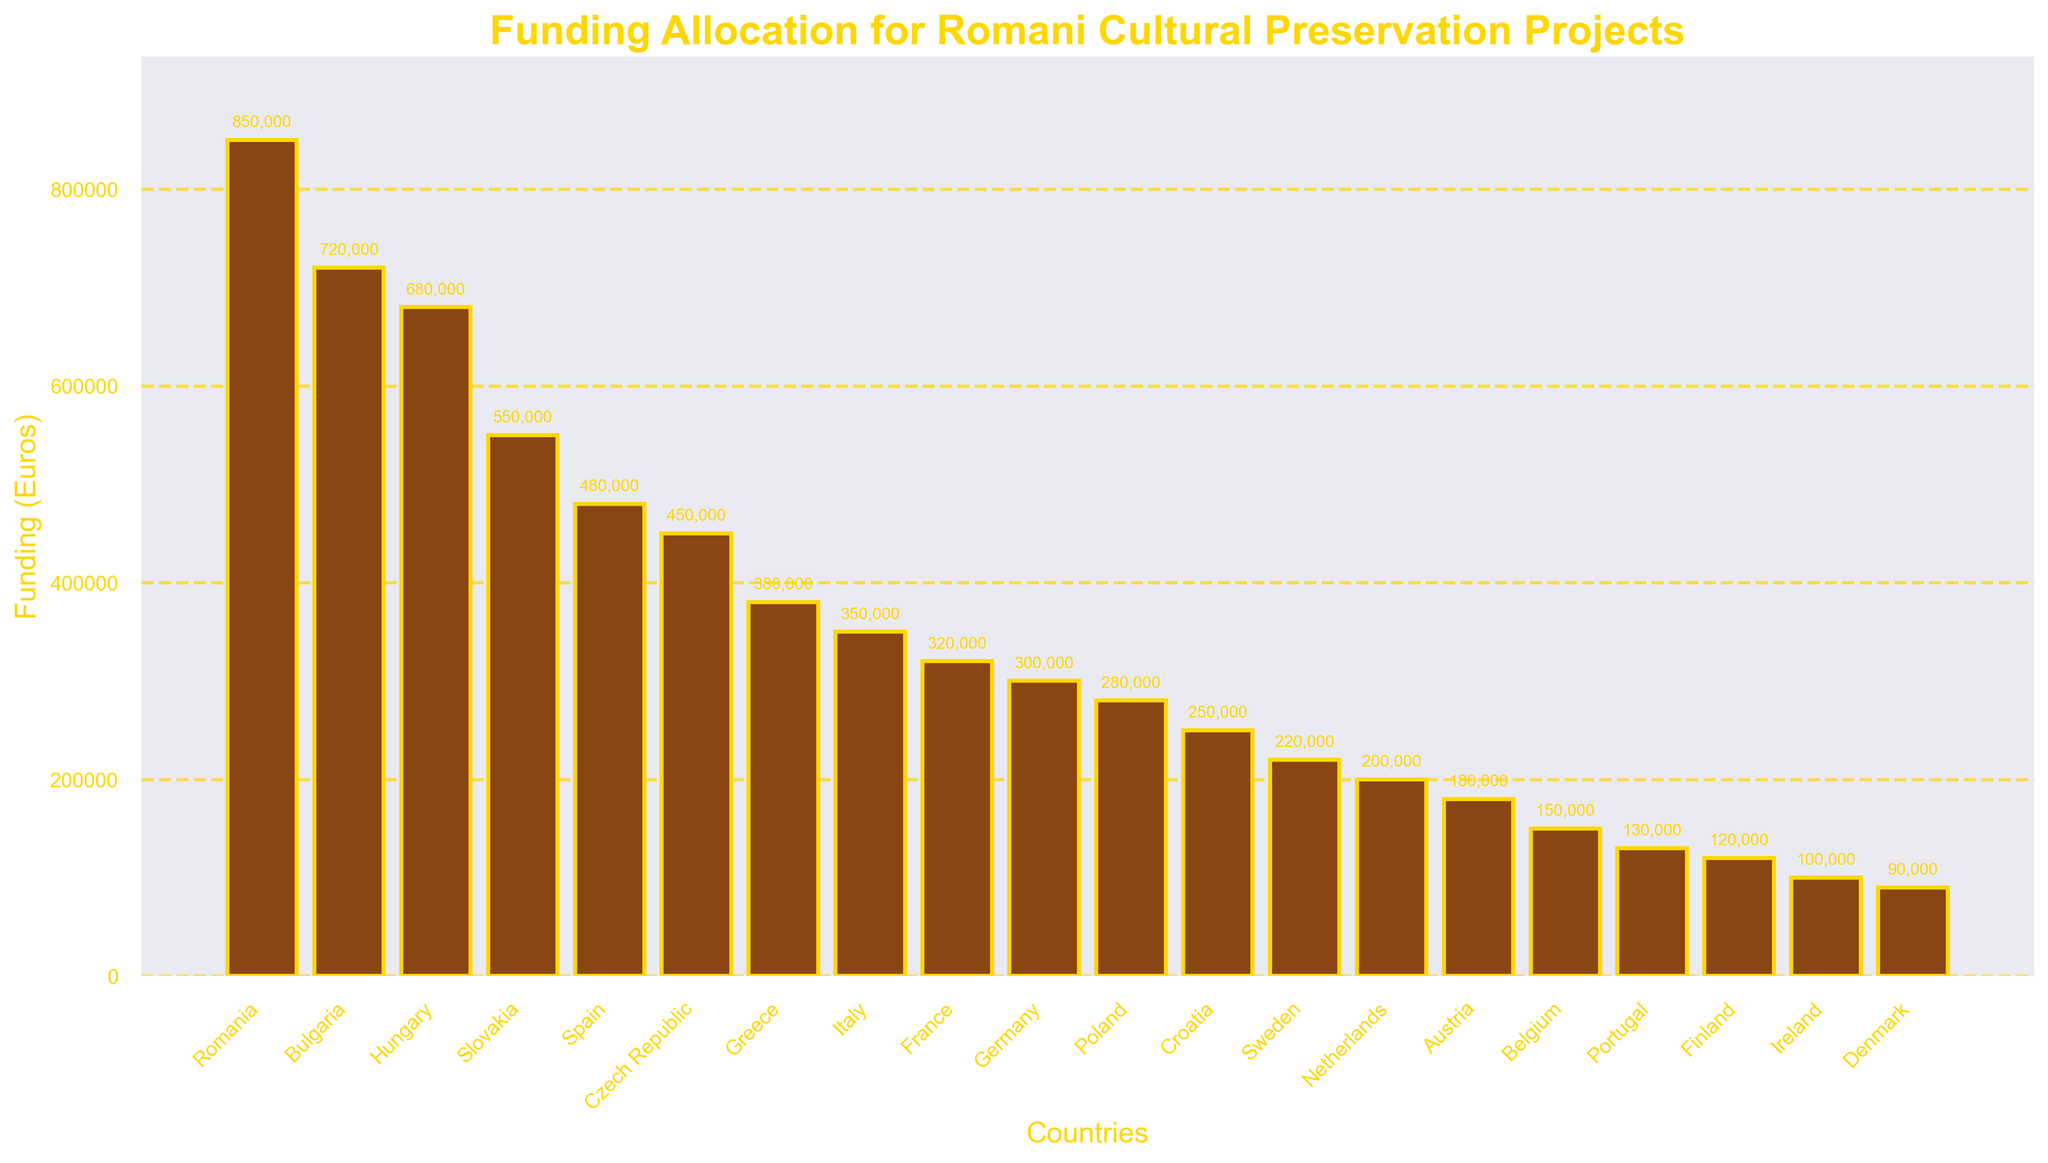what is the total funding allocated by the top three countries? Add the funding amounts for Romania, Bulgaria, and Hungary: 850,000 + 720,000 + 680,000 = 2,250,000 euros
Answer: 2,250,000 euros Which country received the least funding? Look at the bar with the smallest height; Denmark has the smallest bar at 90,000 euros
Answer: Denmark What is the average funding allocated across all countries? Sum the funding amounts for all countries and divide by the number of countries. The sum is 6,840,000 euros. There are 20 countries. Average = 6,840,000 / 20 = 342,000 euros
Answer: 342,000 euros Which countries have a funding allocation of more than 400,000 euros but less than 500,000 euros? Identify bars with heights between 400,000 and 500,000 euros. Spain (480,000 euros) and Czech Republic (450,000 euros) fit the criteria
Answer: Spain, Czech Republic How many countries have a funding allocation of less than 300,000 euros? Count the bars with heights less than 300,000 euros. There are 7 such countries: Poland, Croatia, Sweden, Netherlands, Austria, Belgium, Portugal, Finland, Ireland, Denmark.
Answer: 10 What's the difference in funding between the highest and lowest funded countries? Subtract the lowest funding amount (Denmark; 90,000 euros) from the highest funding amount (Romania; 850,000 euros): 850,000 - 90,000 = 760,000 euros
Answer: 760,000 euros Which country received slightly more funding: France or Germany? Compare the heights of the bars for France and Germany. France received 320,000 euros while Germany received 300,000 euros, so France received more funding
Answer: France Is the sum of the funding allocations of all countries with less than 200,000 euros more than 500,000 euros? Sum the amounts for Netherlands, Austria, Belgium, Portugal, Finland, Ireland, and Denmark: 200,000 + 180,000 + 150,000 + 130,000 + 120,000 + 100,000 + 90,000 = 970,000 euros. 970,000 is greater than 500,000 euros
Answer: Yes What is the median funding amount? Arrange the values in ascending order and find the middle value. The ordered values: 90,000, 100,000, 120,000, 130,000, 150,000, 180,000, 200,000, 220,000, 250,000, 280,000, 300,000, 320,000, 350,000, 380,000, 450,000, 480,000, 550,000, 680,000, 720,000, 850,000. Median is the average of 10th and 11th values: (280,000 + 300,000) / 2 = 290,000 euros
Answer: 290,000 euros Comparing Slovakia and Spain, which country received more funding? Compare the heights of the bars for Slovakia (550,000 euros) and Spain (480,000 euros). Slovakia received more funding
Answer: Slovakia 